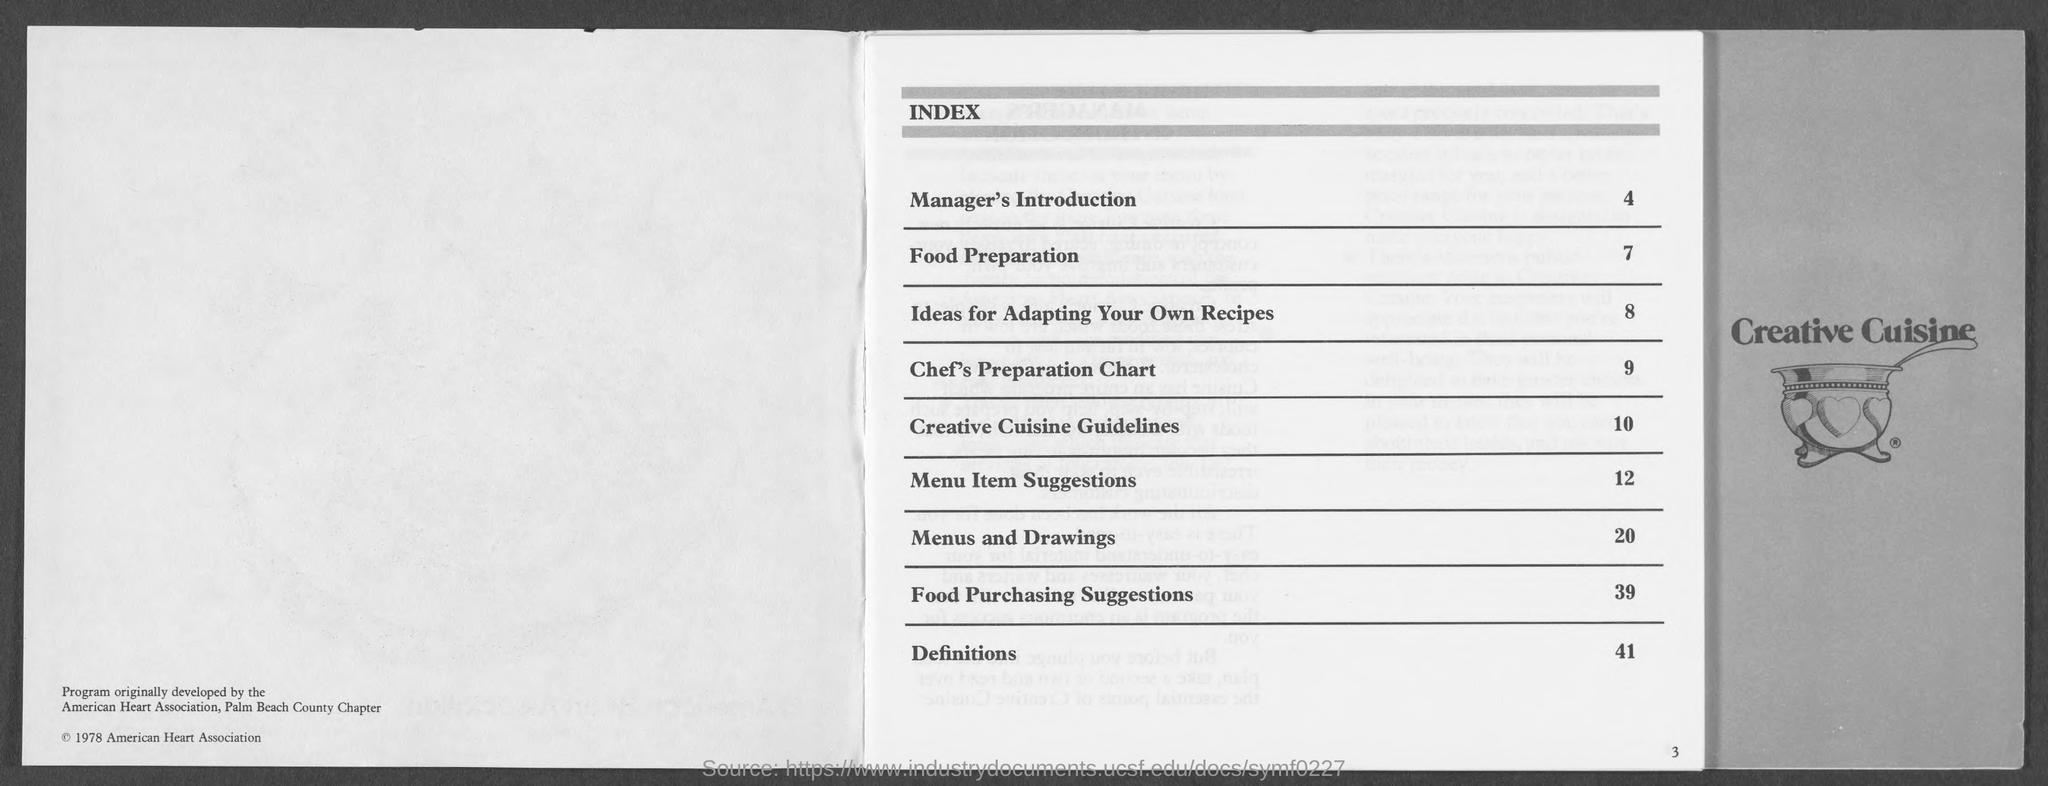Draw attention to some important aspects in this diagram. The page number of "food preparation" is 7. Page 9 contains a chef's preparation chart. Page 10 contains the Creative Cuisine Guidelines. There is a definition on page 41. Page 20 contains menus and drawings. 